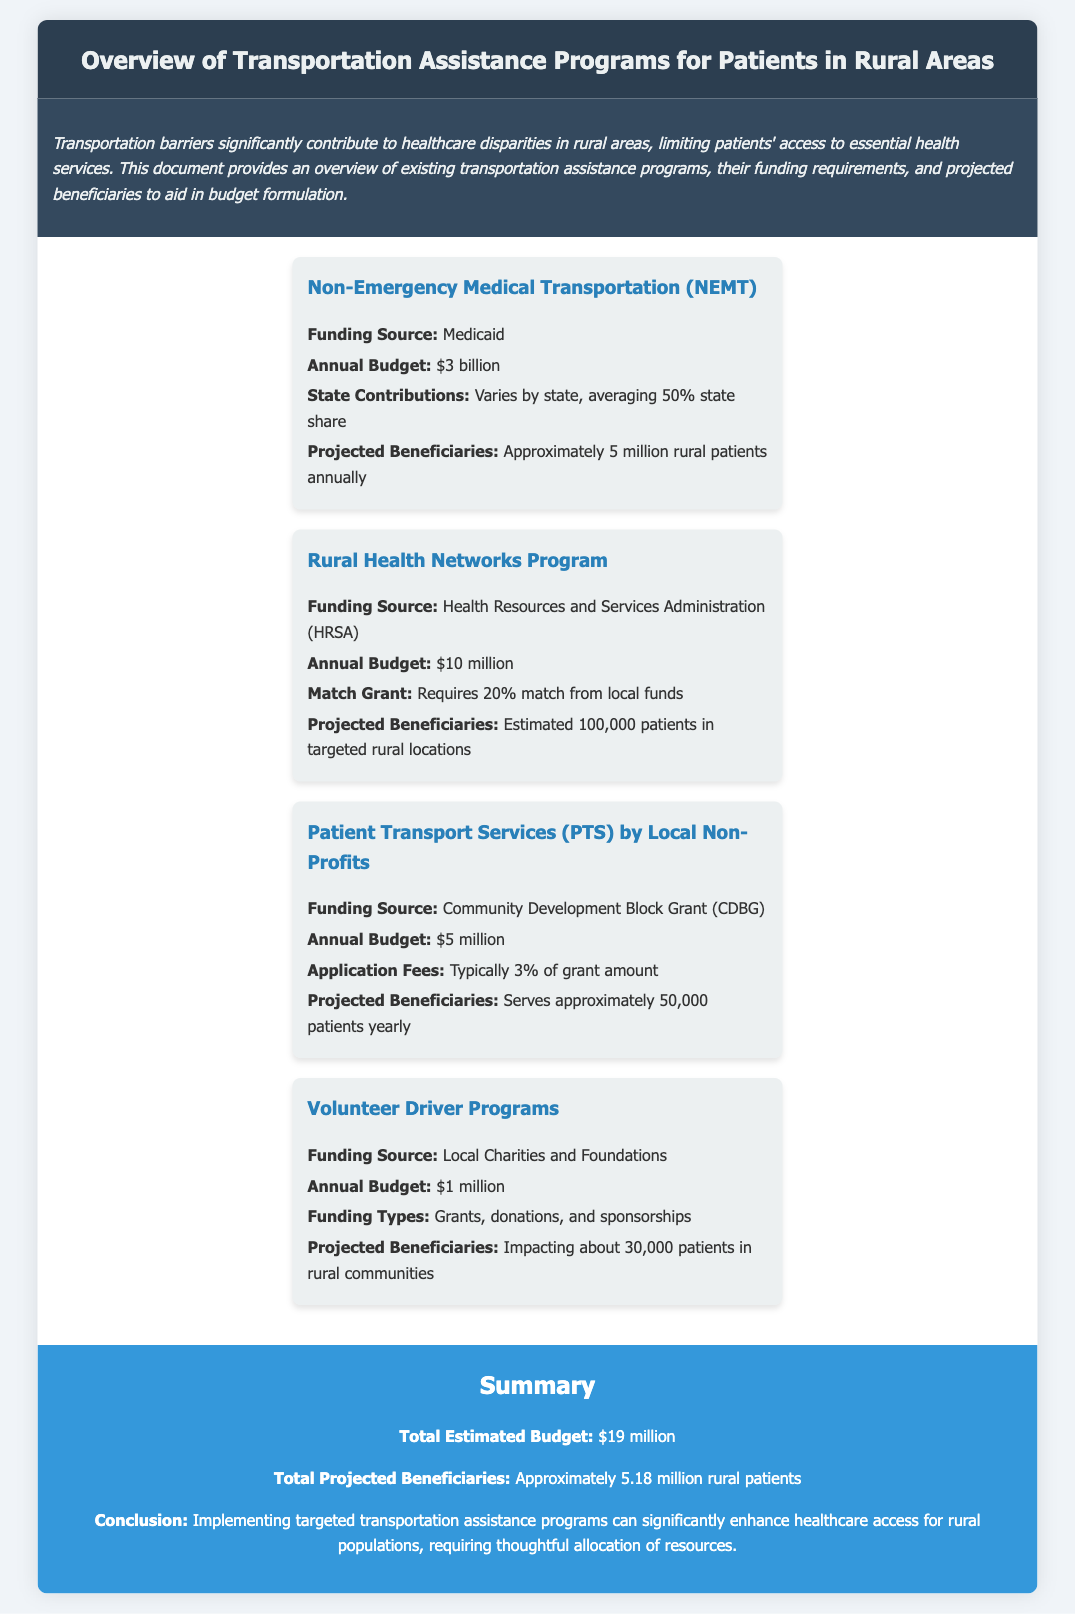What is the funding source for Non-Emergency Medical Transportation? The funding source for Non-Emergency Medical Transportation is Medicaid, as indicated in the program overview.
Answer: Medicaid What is the annual budget for the Rural Health Networks Program? The annual budget for the Rural Health Networks Program is reported to be $10 million.
Answer: $10 million How many rural patients are projected to be served by Patient Transport Services? The projected number of beneficiaries for Patient Transport Services is approximately 50,000 patients yearly.
Answer: 50,000 patients What percentage of state contributions is averaged for Non-Emergency Medical Transportation? The average share of state contributions for Non-Emergency Medical Transportation is 50%.
Answer: 50% What is the total estimated budget for all transportation assistance programs listed? The total estimated budget is calculated by summing the budgets of all programs mentioned, which is $3 billion + $10 million + $5 million + $1 million = $19 million.
Answer: $19 million How many patients does the Volunteer Driver Programs impact? Volunteer Driver Programs are said to impact about 30,000 patients in rural communities.
Answer: 30,000 patients What is the matching grant requirement for the Rural Health Networks Program? The Rural Health Networks Program requires a 20% match from local funds as a condition for funding.
Answer: 20% match What is the total number of projected beneficiaries across all programs? The total projected beneficiaries is derived by adding the beneficiaries from each program, resulting in approximately 5.18 million rural patients.
Answer: 5.18 million patients What is the funding source for Patient Transport Services? Patient Transport Services are funded through the Community Development Block Grant.
Answer: Community Development Block Grant 